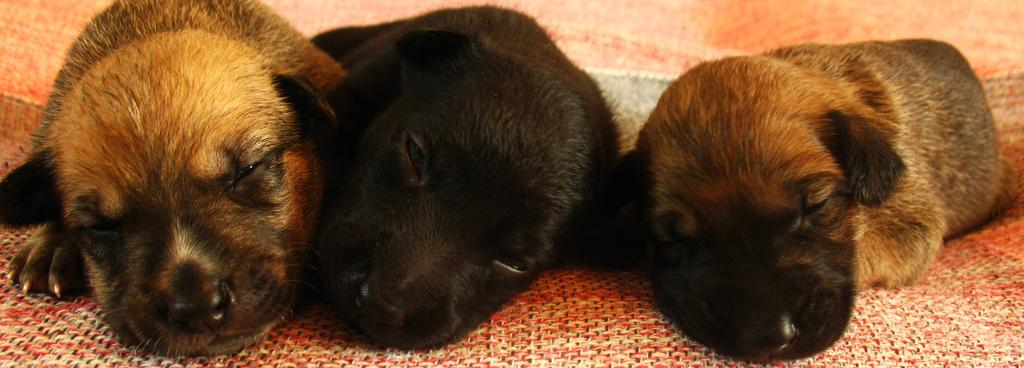How many puppies are present in the image? There are three puppies in the image. What are the colors of the puppies? Two of the puppies are brown, and one is black. What type of footwear is the puppy wearing in the image? There are no puppies wearing footwear in the image, as puppies do not wear footwear. 